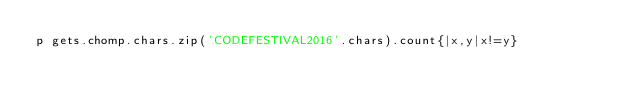Convert code to text. <code><loc_0><loc_0><loc_500><loc_500><_Ruby_>p gets.chomp.chars.zip('CODEFESTIVAL2016'.chars).count{|x,y|x!=y}</code> 